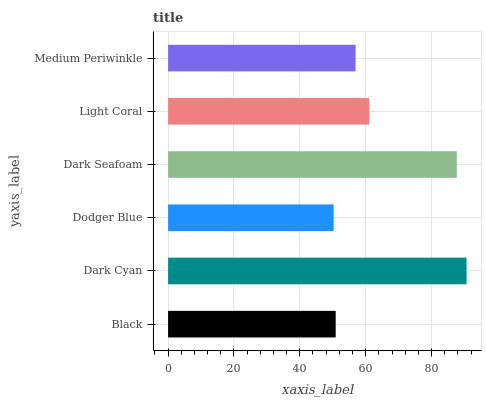Is Dodger Blue the minimum?
Answer yes or no. Yes. Is Dark Cyan the maximum?
Answer yes or no. Yes. Is Dark Cyan the minimum?
Answer yes or no. No. Is Dodger Blue the maximum?
Answer yes or no. No. Is Dark Cyan greater than Dodger Blue?
Answer yes or no. Yes. Is Dodger Blue less than Dark Cyan?
Answer yes or no. Yes. Is Dodger Blue greater than Dark Cyan?
Answer yes or no. No. Is Dark Cyan less than Dodger Blue?
Answer yes or no. No. Is Light Coral the high median?
Answer yes or no. Yes. Is Medium Periwinkle the low median?
Answer yes or no. Yes. Is Dodger Blue the high median?
Answer yes or no. No. Is Black the low median?
Answer yes or no. No. 